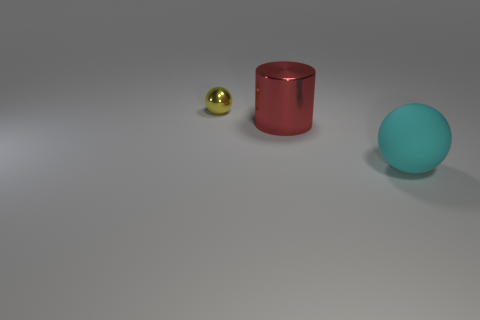Add 3 big metal cylinders. How many objects exist? 6 Subtract all cylinders. How many objects are left? 2 Add 1 large red metal blocks. How many large red metal blocks exist? 1 Subtract 0 brown cubes. How many objects are left? 3 Subtract all small gray matte cubes. Subtract all small objects. How many objects are left? 2 Add 1 cylinders. How many cylinders are left? 2 